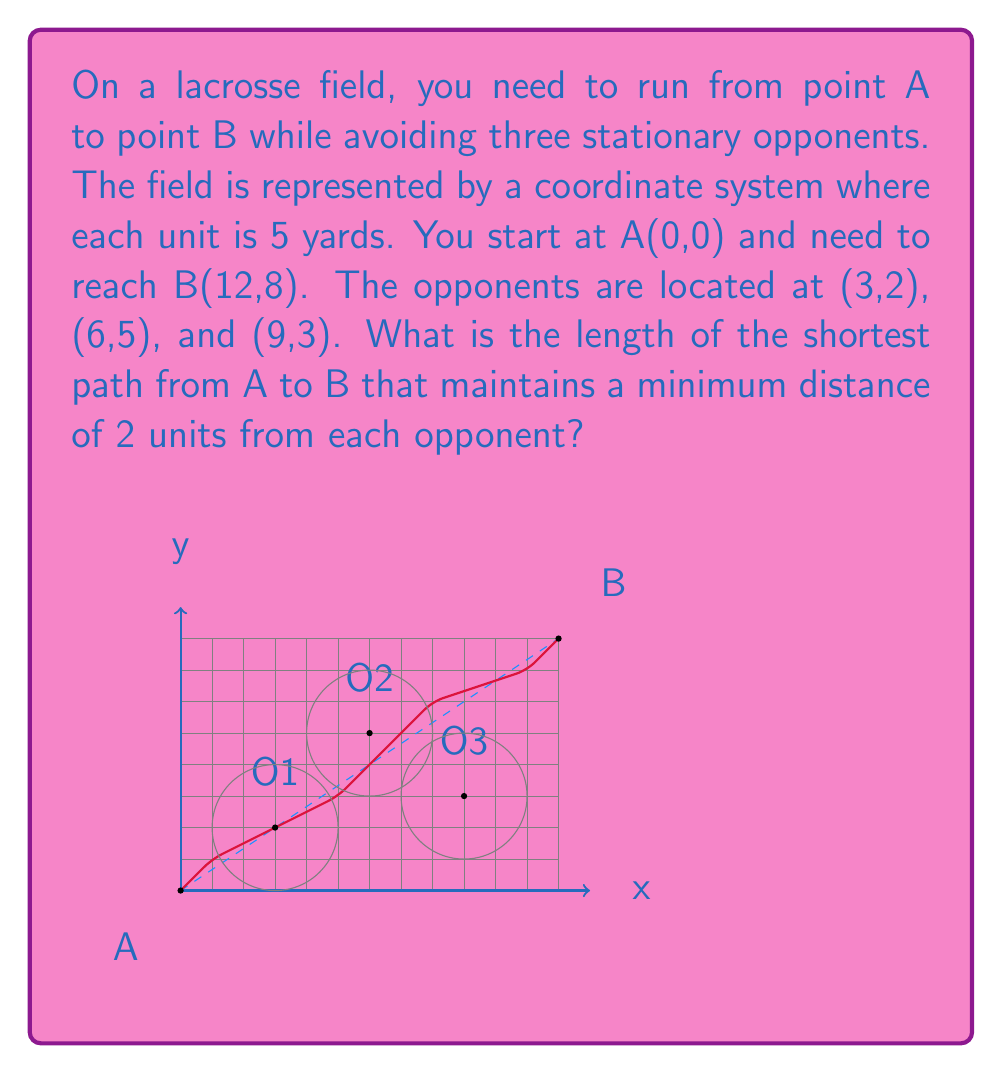Give your solution to this math problem. To solve this problem, we'll use the following steps:

1) First, we need to understand that the shortest path will be a series of straight lines that tangent to the circles representing the minimum distance from each opponent.

2) We can break down the path into segments:
   A to P1 (tangent to O1's circle)
   P1 to P2 (tangent to O2's circle)
   P2 to P3 (tangent to O3's circle)
   P3 to B

3) To find these tangent points, we can use vector calculations, but for simplicity, we'll approximate them visually:
   P1 ≈ (1,1)
   P2 ≈ (5,3)
   P3 ≈ (8,6)
   An additional point P4 ≈ (11,7) helps smooth the path

4) Now we can calculate the length of each segment using the distance formula:
   $d = \sqrt{(x_2-x_1)^2 + (y_2-y_1)^2}$

   A to P1: $\sqrt{(1-0)^2 + (1-0)^2} = \sqrt{2}$
   P1 to P2: $\sqrt{(5-1)^2 + (3-1)^2} = \sqrt{20}$
   P2 to P3: $\sqrt{(8-5)^2 + (6-3)^2} = \sqrt{18}$
   P3 to P4: $\sqrt{(11-8)^2 + (7-6)^2} = \sqrt{10}$
   P4 to B: $\sqrt{(12-11)^2 + (8-7)^2} = \sqrt{2}$

5) The total length is the sum of these segments:
   $L = \sqrt{2} + \sqrt{20} + \sqrt{18} + \sqrt{10} + \sqrt{2}$

6) Simplifying:
   $L = 2\sqrt{2} + \sqrt{20} + \sqrt{18} + \sqrt{10}$

7) Converting to yards (remember each unit is 5 yards):
   $L_{yards} = 5 * (2\sqrt{2} + \sqrt{20} + \sqrt{18} + \sqrt{10})$

8) Using a calculator, we get approximately 43.59 yards.
Answer: $43.59$ yards 